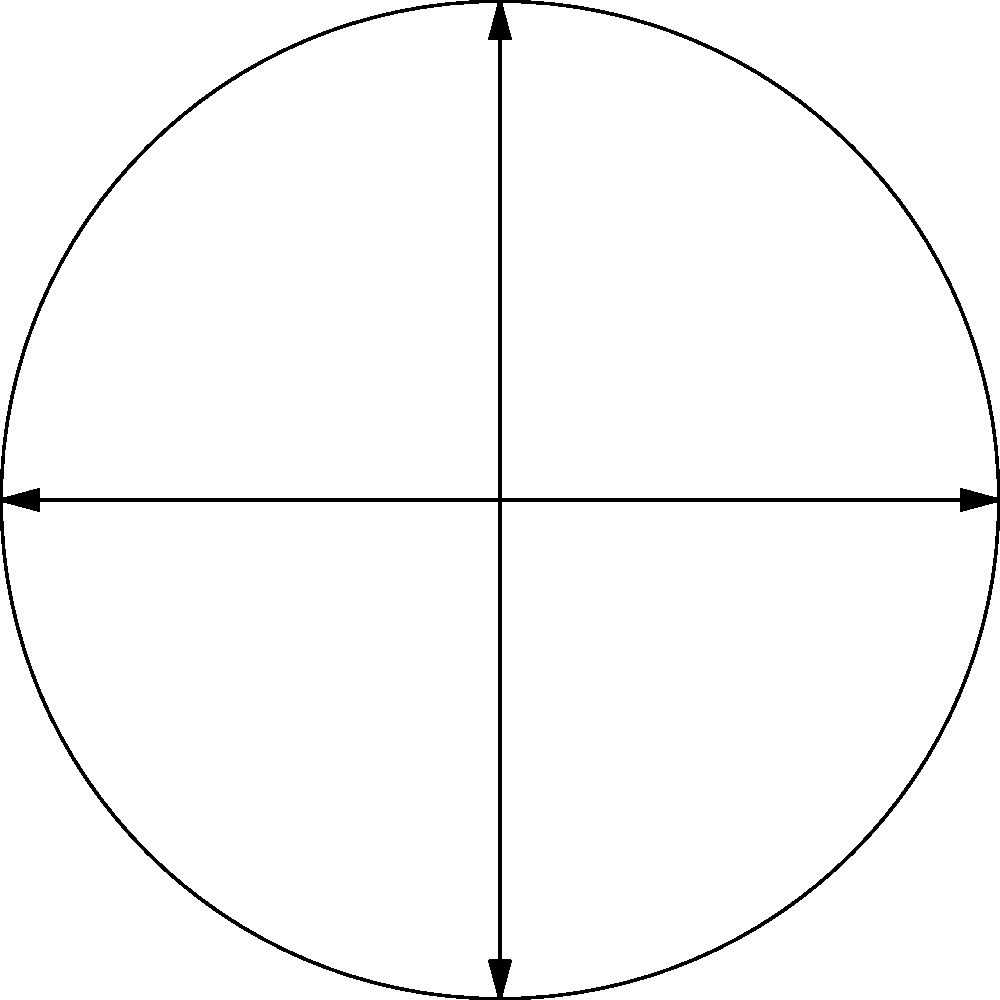As an HR manager implementing a circular employee benefits package diagram based on behavioral economics principles, you've created a visual representation where the total area represents the company's investment in benefits. The circle has a radius of 10 units, and the sectors represent different benefit categories: Health (40%), Retirement (30%), PTO (20%), and Other (10%). Calculate the area of the sector representing the Retirement benefits. To calculate the area of the Retirement benefits sector, we'll follow these steps:

1) The formula for the area of a circle is $A = \pi r^2$, where $r$ is the radius.

2) Given radius $r = 10$ units, the total area of the circle is:
   $A_{total} = \pi (10)^2 = 100\pi$ square units

3) The Retirement benefits sector represents 30% of the total area.
   To calculate this, we multiply the total area by 0.30:
   
   $A_{retirement} = 100\pi \times 0.30 = 30\pi$ square units

4) We can also derive this using the formula for the area of a sector:
   $A_{sector} = \frac{\theta}{360°} \pi r^2$
   
   Where $\theta$ is the central angle in degrees.
   For 30% of a circle, $\theta = 0.30 \times 360° = 108°$

   $A_{retirement} = \frac{108°}{360°} \pi (10)^2 = 0.3 \times 100\pi = 30\pi$ square units

Therefore, the area of the Retirement benefits sector is $30\pi$ square units.
Answer: $30\pi$ square units 